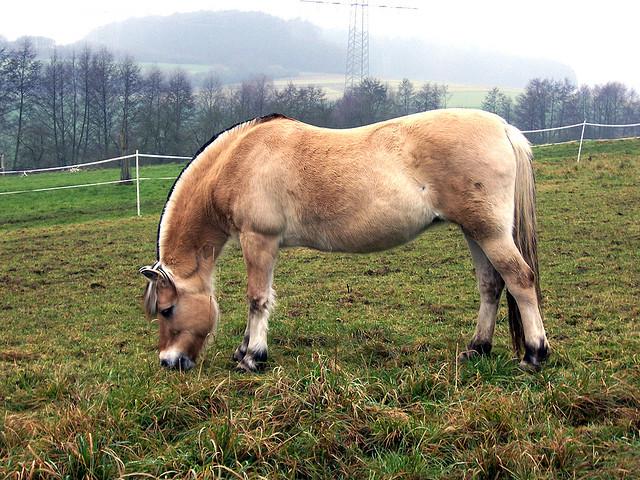How many animals?
Answer briefly. 1. Is it daytime?
Answer briefly. Yes. What color is the horse?
Be succinct. Tan. Is the grass green?
Be succinct. Yes. 